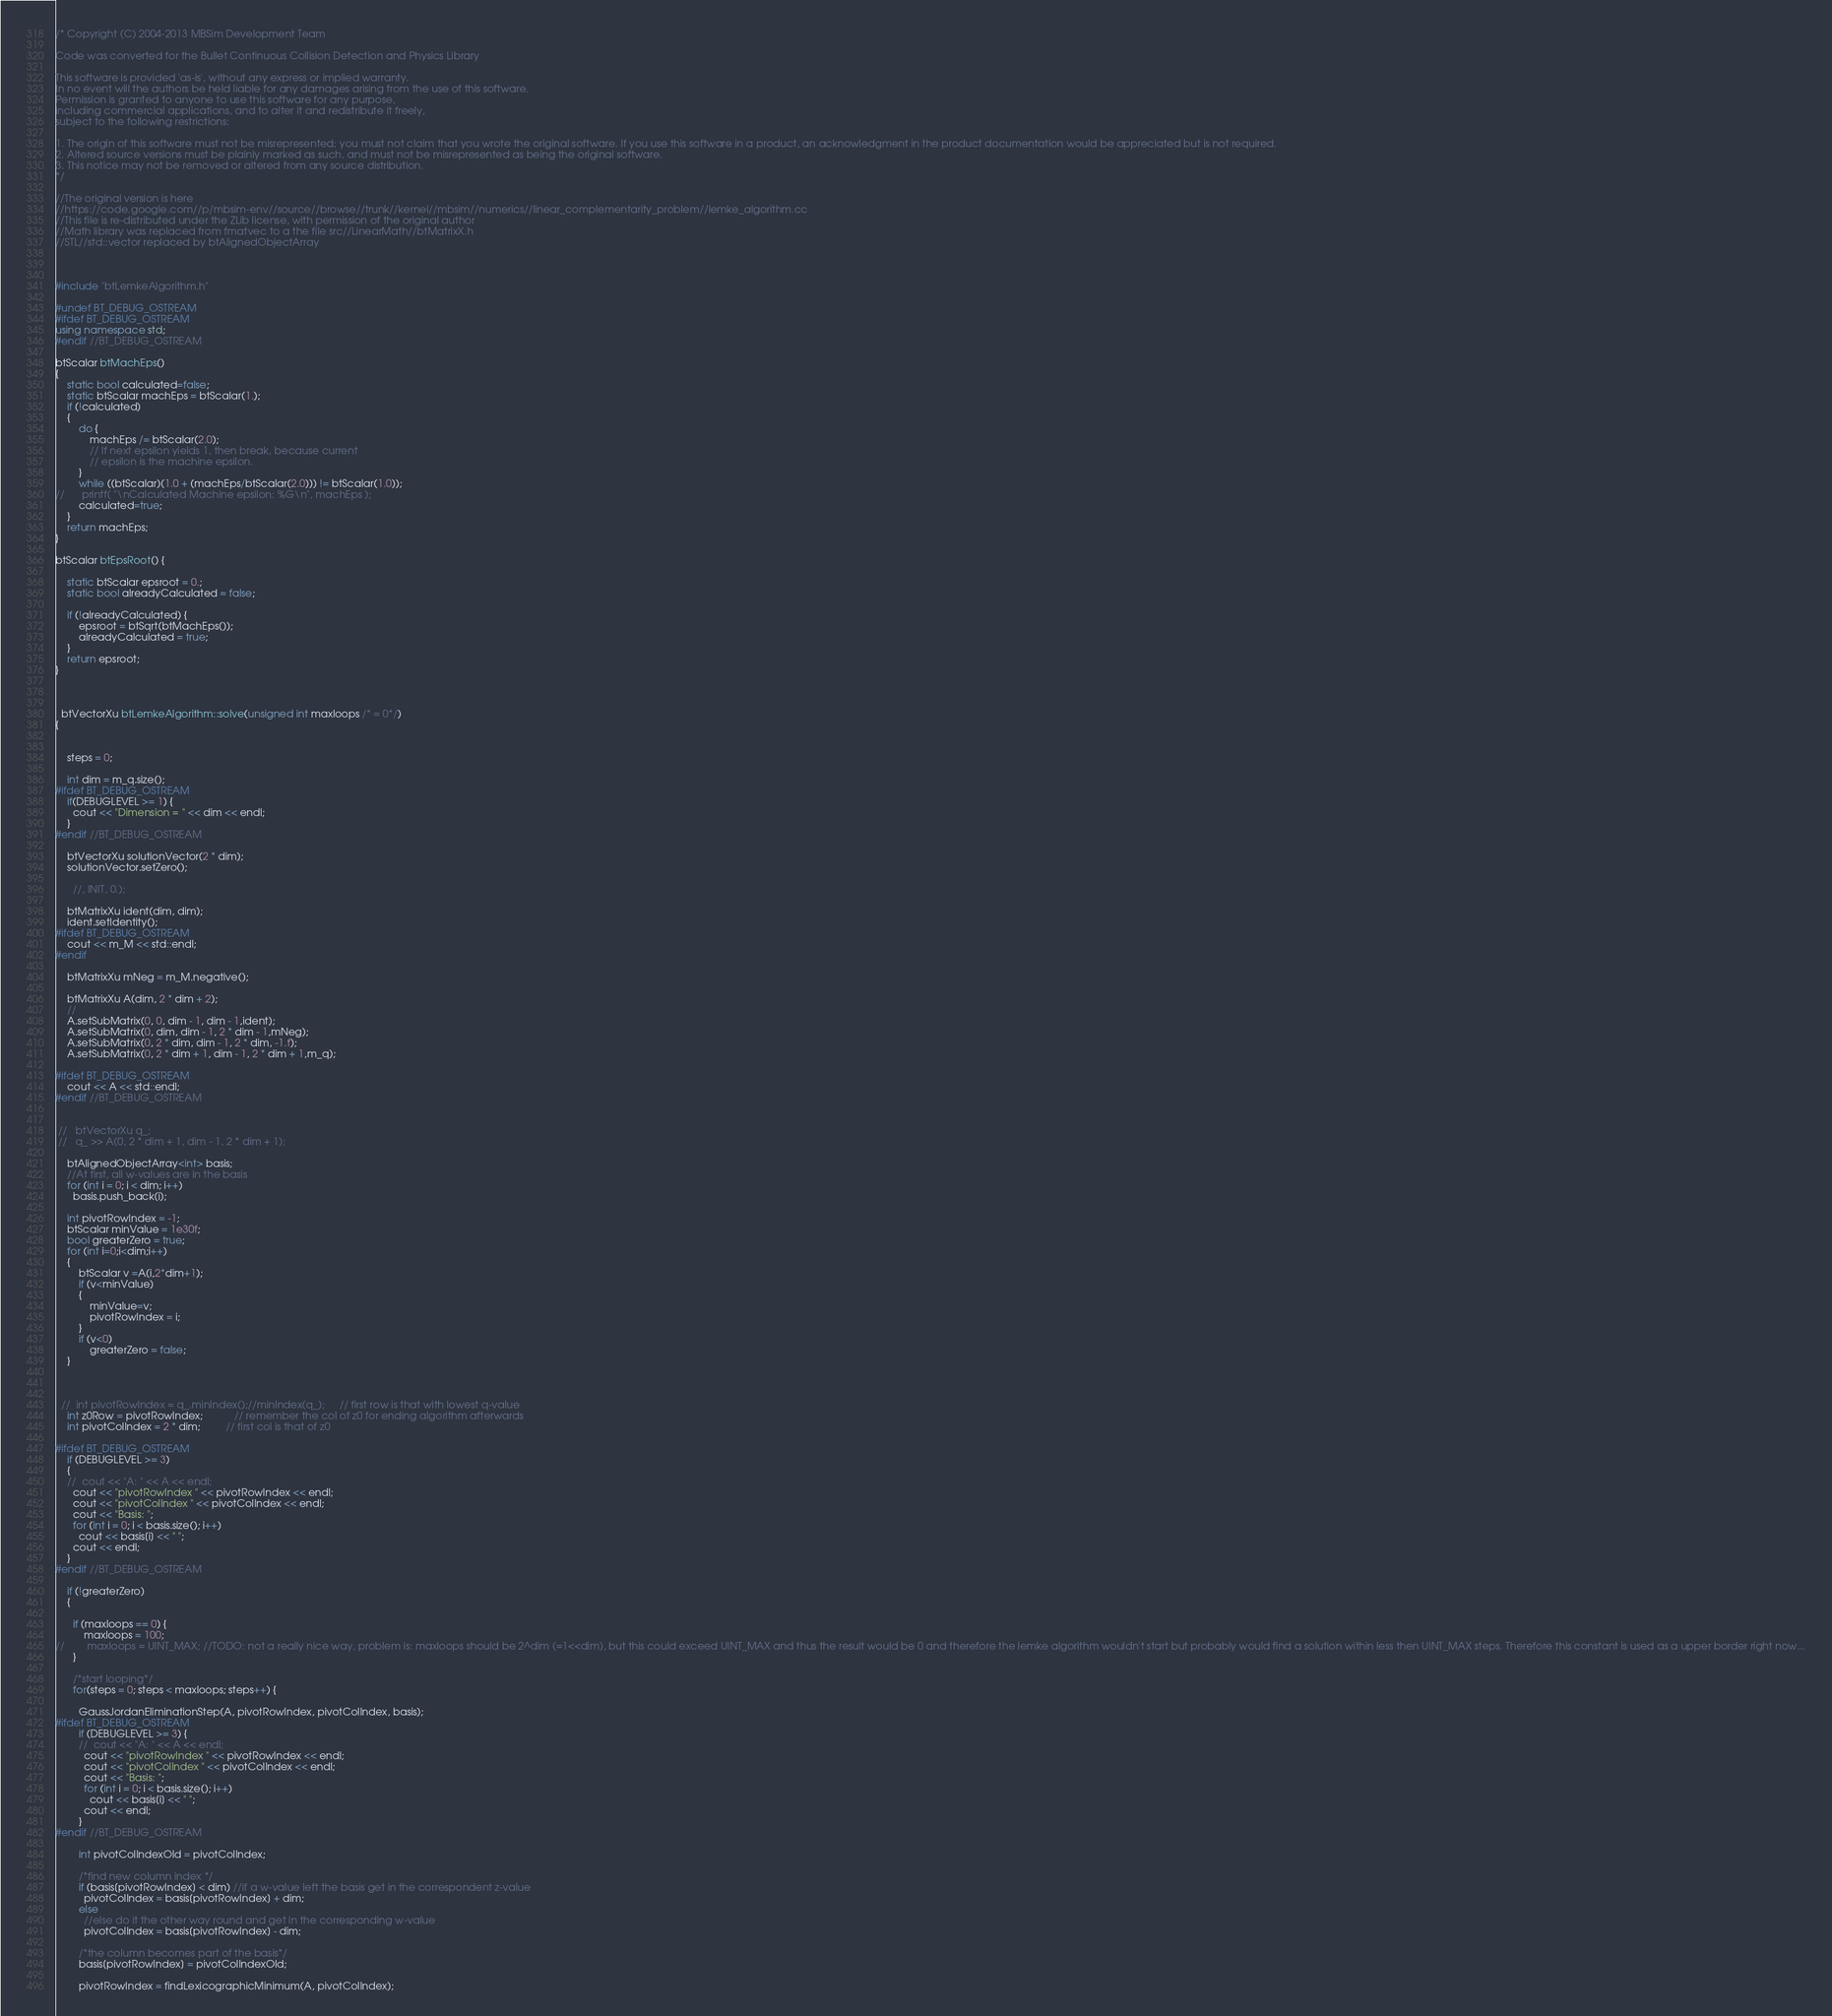Convert code to text. <code><loc_0><loc_0><loc_500><loc_500><_C++_>/* Copyright (C) 2004-2013 MBSim Development Team

Code was converted for the Bullet Continuous Collision Detection and Physics Library

This software is provided 'as-is', without any express or implied warranty.
In no event will the authors be held liable for any damages arising from the use of this software.
Permission is granted to anyone to use this software for any purpose, 
including commercial applications, and to alter it and redistribute it freely, 
subject to the following restrictions:

1. The origin of this software must not be misrepresented; you must not claim that you wrote the original software. If you use this software in a product, an acknowledgment in the product documentation would be appreciated but is not required.
2. Altered source versions must be plainly marked as such, and must not be misrepresented as being the original software.
3. This notice may not be removed or altered from any source distribution.
*/

//The original version is here
//https://code.google.com//p/mbsim-env//source//browse//trunk//kernel//mbsim//numerics//linear_complementarity_problem//lemke_algorithm.cc
//This file is re-distributed under the ZLib license, with permission of the original author
//Math library was replaced from fmatvec to a the file src//LinearMath//btMatrixX.h
//STL//std::vector replaced by btAlignedObjectArray



#include "btLemkeAlgorithm.h"

#undef BT_DEBUG_OSTREAM
#ifdef BT_DEBUG_OSTREAM
using namespace std;
#endif //BT_DEBUG_OSTREAM

btScalar btMachEps()
{
	static bool calculated=false;
	static btScalar machEps = btScalar(1.);
	if (!calculated)
	{
		do {
			machEps /= btScalar(2.0);
			// If next epsilon yields 1, then break, because current
			// epsilon is the machine epsilon.
		}
		while ((btScalar)(1.0 + (machEps/btScalar(2.0))) != btScalar(1.0));
//		printf( "\nCalculated Machine epsilon: %G\n", machEps );
		calculated=true;
	}
	return machEps;
}

btScalar btEpsRoot() {
	
	static btScalar epsroot = 0.;
	static bool alreadyCalculated = false;
	
	if (!alreadyCalculated) {
		epsroot = btSqrt(btMachEps());
		alreadyCalculated = true;
	}
	return epsroot;
}

	 

  btVectorXu btLemkeAlgorithm::solve(unsigned int maxloops /* = 0*/)
{
  
    
    steps = 0;

    int dim = m_q.size();
#ifdef BT_DEBUG_OSTREAM
    if(DEBUGLEVEL >= 1) {
      cout << "Dimension = " << dim << endl;
    }
#endif //BT_DEBUG_OSTREAM

	btVectorXu solutionVector(2 * dim);
	solutionVector.setZero();
	  
	  //, INIT, 0.);

	btMatrixXu ident(dim, dim);
	ident.setIdentity();
#ifdef BT_DEBUG_OSTREAM
	cout << m_M << std::endl;
#endif

	btMatrixXu mNeg = m_M.negative();
	  
    btMatrixXu A(dim, 2 * dim + 2);
	//
	A.setSubMatrix(0, 0, dim - 1, dim - 1,ident);
	A.setSubMatrix(0, dim, dim - 1, 2 * dim - 1,mNeg);
	A.setSubMatrix(0, 2 * dim, dim - 1, 2 * dim, -1.f);
	A.setSubMatrix(0, 2 * dim + 1, dim - 1, 2 * dim + 1,m_q);

#ifdef BT_DEBUG_OSTREAM
	cout << A << std::endl;
#endif //BT_DEBUG_OSTREAM


 //   btVectorXu q_;
 //   q_ >> A(0, 2 * dim + 1, dim - 1, 2 * dim + 1);

    btAlignedObjectArray<int> basis;
    //At first, all w-values are in the basis
    for (int i = 0; i < dim; i++)
      basis.push_back(i);

	int pivotRowIndex = -1;
	btScalar minValue = 1e30f;
	bool greaterZero = true;
	for (int i=0;i<dim;i++)
	{
		btScalar v =A(i,2*dim+1);
		if (v<minValue)
		{
			minValue=v;
			pivotRowIndex = i;
		}
		if (v<0)
			greaterZero = false;
	}
	

	
  //  int pivotRowIndex = q_.minIndex();//minIndex(q_);     // first row is that with lowest q-value
    int z0Row = pivotRowIndex;           // remember the col of z0 for ending algorithm afterwards
    int pivotColIndex = 2 * dim;         // first col is that of z0

#ifdef BT_DEBUG_OSTREAM
    if (DEBUGLEVEL >= 3)
	{
    //  cout << "A: " << A << endl;
      cout << "pivotRowIndex " << pivotRowIndex << endl;
      cout << "pivotColIndex " << pivotColIndex << endl;
      cout << "Basis: ";
      for (int i = 0; i < basis.size(); i++)
        cout << basis[i] << " ";
      cout << endl;
    }
#endif //BT_DEBUG_OSTREAM

	if (!greaterZero)
	{

      if (maxloops == 0) {
		  maxloops = 100;
//        maxloops = UINT_MAX; //TODO: not a really nice way, problem is: maxloops should be 2^dim (=1<<dim), but this could exceed UINT_MAX and thus the result would be 0 and therefore the lemke algorithm wouldn't start but probably would find a solution within less then UINT_MAX steps. Therefore this constant is used as a upper border right now...
      }

      /*start looping*/
      for(steps = 0; steps < maxloops; steps++) {

        GaussJordanEliminationStep(A, pivotRowIndex, pivotColIndex, basis);
#ifdef BT_DEBUG_OSTREAM
        if (DEBUGLEVEL >= 3) {
        //  cout << "A: " << A << endl;
          cout << "pivotRowIndex " << pivotRowIndex << endl;
          cout << "pivotColIndex " << pivotColIndex << endl;
          cout << "Basis: ";
          for (int i = 0; i < basis.size(); i++)
            cout << basis[i] << " ";
          cout << endl;
        }
#endif //BT_DEBUG_OSTREAM

        int pivotColIndexOld = pivotColIndex;

        /*find new column index */
        if (basis[pivotRowIndex] < dim) //if a w-value left the basis get in the correspondent z-value
          pivotColIndex = basis[pivotRowIndex] + dim;
        else
          //else do it the other way round and get in the corresponding w-value
          pivotColIndex = basis[pivotRowIndex] - dim;

        /*the column becomes part of the basis*/
        basis[pivotRowIndex] = pivotColIndexOld;

        pivotRowIndex = findLexicographicMinimum(A, pivotColIndex);
</code> 